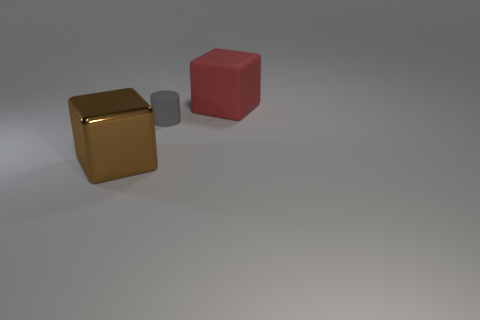There is a block behind the metal block; is it the same size as the brown metal cube?
Your response must be concise. Yes. What shape is the matte thing in front of the large block on the right side of the big brown thing?
Your response must be concise. Cylinder. There is a block in front of the cube to the right of the brown metal block; how big is it?
Make the answer very short. Large. What is the color of the block in front of the tiny gray object?
Give a very brief answer. Brown. The red cube that is made of the same material as the gray thing is what size?
Provide a short and direct response. Large. How many other big shiny things have the same shape as the brown shiny object?
Your answer should be very brief. 0. There is another cube that is the same size as the matte cube; what is its material?
Give a very brief answer. Metal. Are there any large red cubes made of the same material as the tiny gray object?
Keep it short and to the point. Yes. There is a thing that is on the right side of the large metal thing and in front of the red matte cube; what color is it?
Ensure brevity in your answer.  Gray. How many other things are the same color as the tiny matte thing?
Offer a very short reply. 0. 